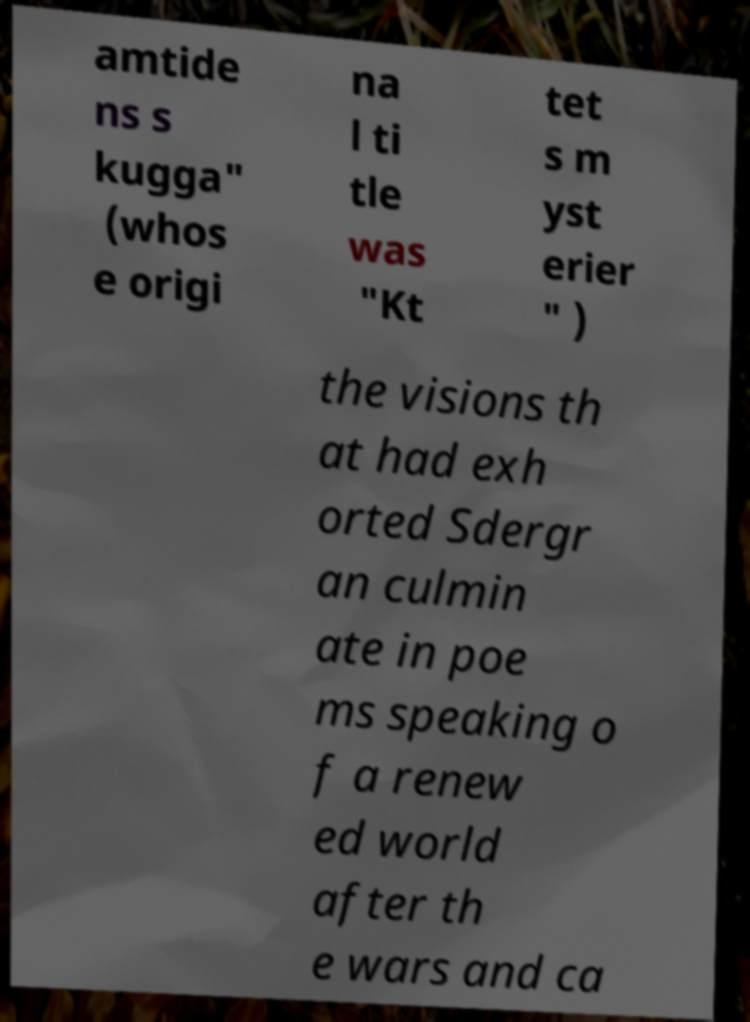Could you assist in decoding the text presented in this image and type it out clearly? amtide ns s kugga" (whos e origi na l ti tle was "Kt tet s m yst erier " ) the visions th at had exh orted Sdergr an culmin ate in poe ms speaking o f a renew ed world after th e wars and ca 